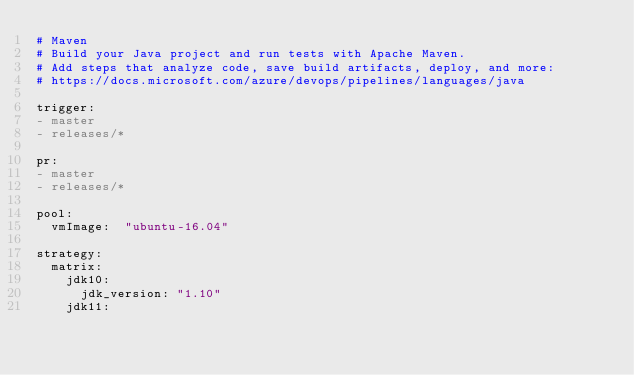<code> <loc_0><loc_0><loc_500><loc_500><_YAML_># Maven
# Build your Java project and run tests with Apache Maven.
# Add steps that analyze code, save build artifacts, deploy, and more:
# https://docs.microsoft.com/azure/devops/pipelines/languages/java

trigger:
- master
- releases/*

pr:
- master
- releases/*

pool:
  vmImage:  "ubuntu-16.04"

strategy:
  matrix:
    jdk10:
      jdk_version: "1.10"
    jdk11:</code> 